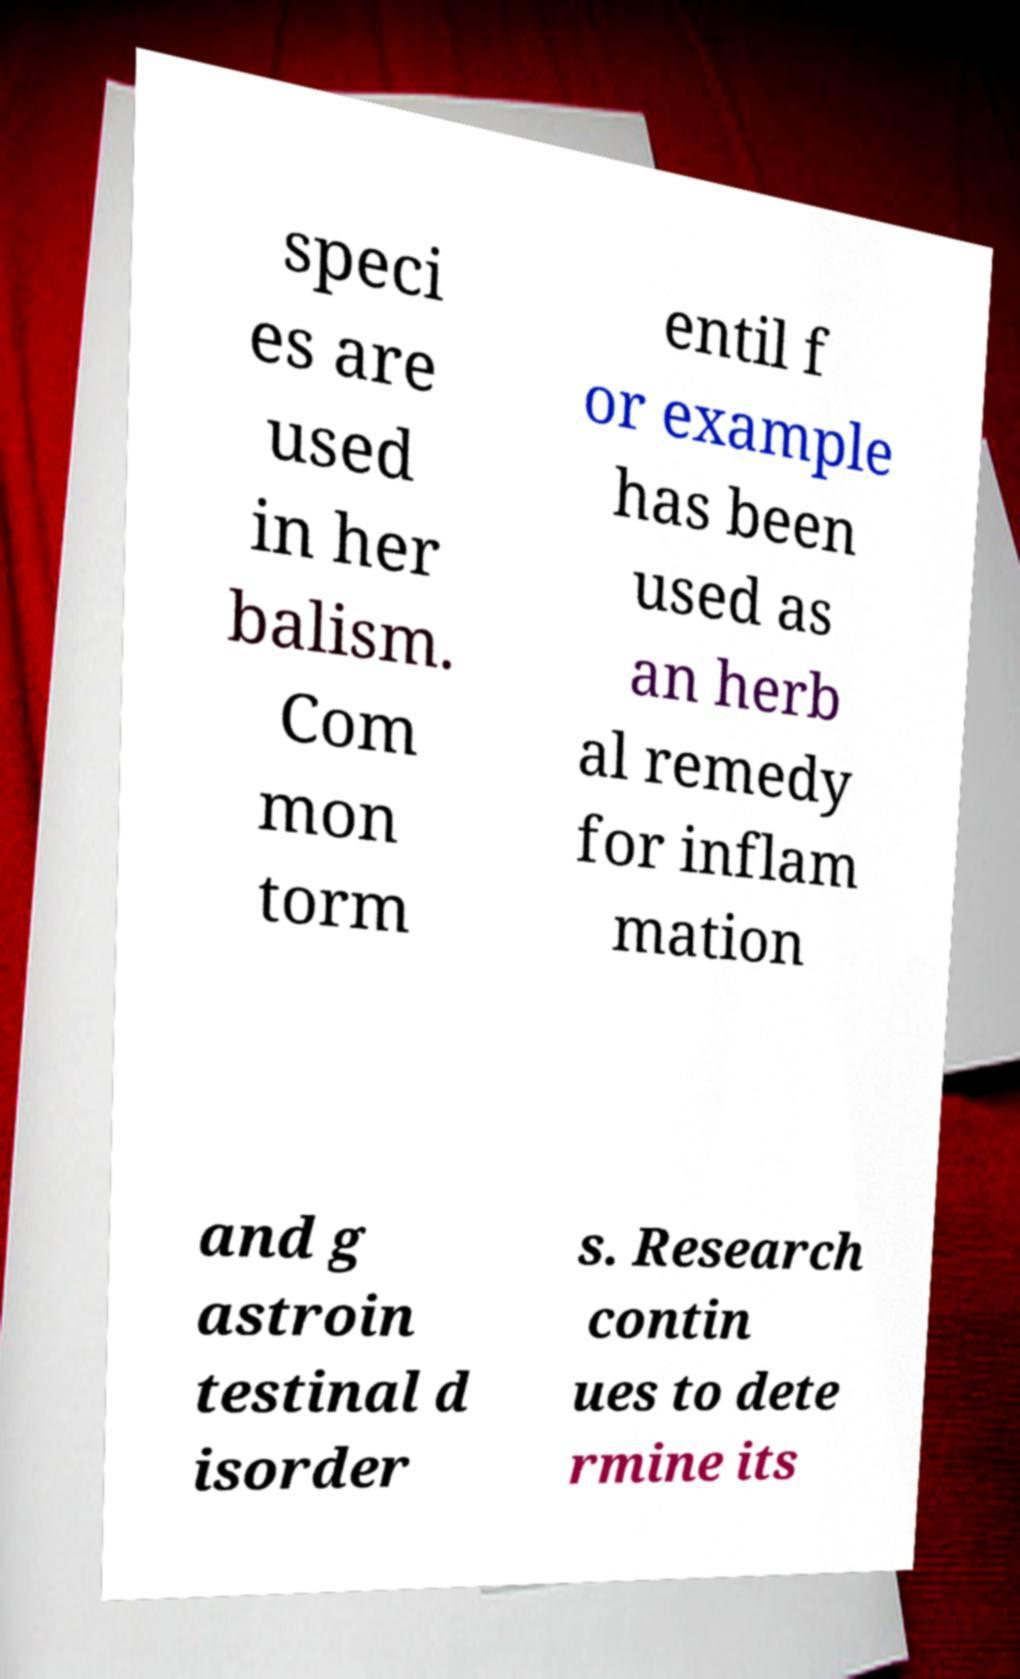Please read and relay the text visible in this image. What does it say? speci es are used in her balism. Com mon torm entil f or example has been used as an herb al remedy for inflam mation and g astroin testinal d isorder s. Research contin ues to dete rmine its 